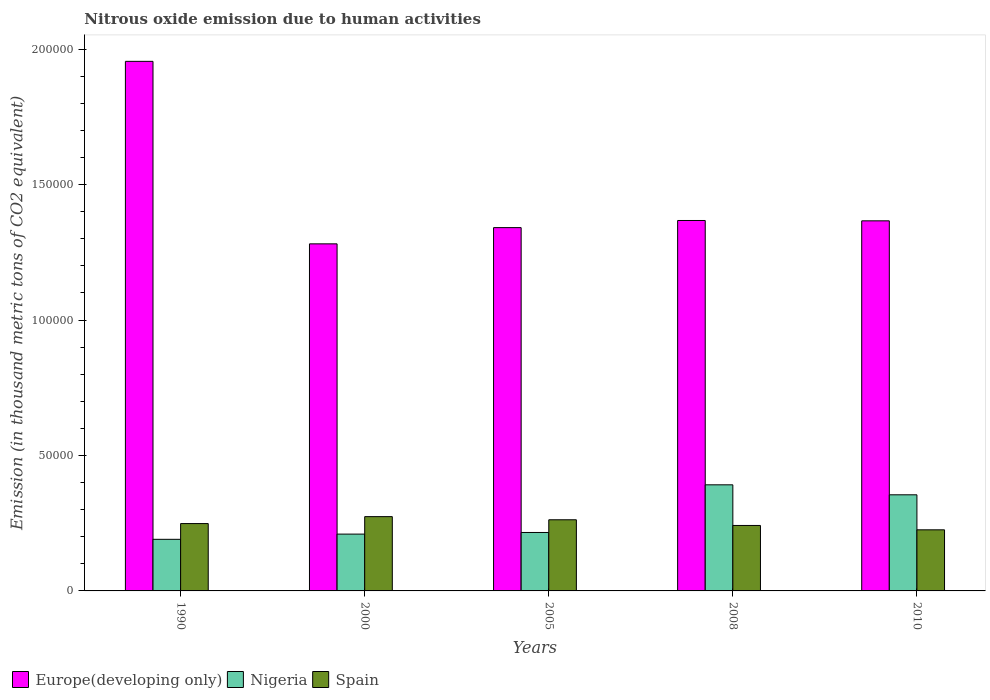How many bars are there on the 1st tick from the left?
Your answer should be compact. 3. What is the label of the 1st group of bars from the left?
Keep it short and to the point. 1990. What is the amount of nitrous oxide emitted in Spain in 2010?
Keep it short and to the point. 2.26e+04. Across all years, what is the maximum amount of nitrous oxide emitted in Nigeria?
Offer a very short reply. 3.92e+04. Across all years, what is the minimum amount of nitrous oxide emitted in Spain?
Offer a very short reply. 2.26e+04. In which year was the amount of nitrous oxide emitted in Nigeria maximum?
Provide a short and direct response. 2008. In which year was the amount of nitrous oxide emitted in Spain minimum?
Ensure brevity in your answer.  2010. What is the total amount of nitrous oxide emitted in Europe(developing only) in the graph?
Ensure brevity in your answer.  7.31e+05. What is the difference between the amount of nitrous oxide emitted in Spain in 2005 and that in 2008?
Give a very brief answer. 2102.5. What is the difference between the amount of nitrous oxide emitted in Spain in 2010 and the amount of nitrous oxide emitted in Europe(developing only) in 2005?
Offer a terse response. -1.12e+05. What is the average amount of nitrous oxide emitted in Europe(developing only) per year?
Provide a short and direct response. 1.46e+05. In the year 1990, what is the difference between the amount of nitrous oxide emitted in Spain and amount of nitrous oxide emitted in Nigeria?
Offer a very short reply. 5814.2. In how many years, is the amount of nitrous oxide emitted in Nigeria greater than 180000 thousand metric tons?
Your answer should be very brief. 0. What is the ratio of the amount of nitrous oxide emitted in Europe(developing only) in 1990 to that in 2000?
Give a very brief answer. 1.53. Is the amount of nitrous oxide emitted in Spain in 2000 less than that in 2005?
Your answer should be compact. No. What is the difference between the highest and the second highest amount of nitrous oxide emitted in Europe(developing only)?
Offer a very short reply. 5.87e+04. What is the difference between the highest and the lowest amount of nitrous oxide emitted in Nigeria?
Offer a very short reply. 2.01e+04. What does the 1st bar from the left in 2010 represents?
Give a very brief answer. Europe(developing only). What is the difference between two consecutive major ticks on the Y-axis?
Your answer should be compact. 5.00e+04. Are the values on the major ticks of Y-axis written in scientific E-notation?
Your response must be concise. No. How are the legend labels stacked?
Provide a short and direct response. Horizontal. What is the title of the graph?
Offer a terse response. Nitrous oxide emission due to human activities. Does "Namibia" appear as one of the legend labels in the graph?
Offer a very short reply. No. What is the label or title of the Y-axis?
Offer a very short reply. Emission (in thousand metric tons of CO2 equivalent). What is the Emission (in thousand metric tons of CO2 equivalent) in Europe(developing only) in 1990?
Provide a short and direct response. 1.95e+05. What is the Emission (in thousand metric tons of CO2 equivalent) of Nigeria in 1990?
Your answer should be very brief. 1.90e+04. What is the Emission (in thousand metric tons of CO2 equivalent) of Spain in 1990?
Give a very brief answer. 2.49e+04. What is the Emission (in thousand metric tons of CO2 equivalent) of Europe(developing only) in 2000?
Ensure brevity in your answer.  1.28e+05. What is the Emission (in thousand metric tons of CO2 equivalent) of Nigeria in 2000?
Offer a very short reply. 2.10e+04. What is the Emission (in thousand metric tons of CO2 equivalent) of Spain in 2000?
Ensure brevity in your answer.  2.74e+04. What is the Emission (in thousand metric tons of CO2 equivalent) of Europe(developing only) in 2005?
Provide a succinct answer. 1.34e+05. What is the Emission (in thousand metric tons of CO2 equivalent) in Nigeria in 2005?
Offer a terse response. 2.16e+04. What is the Emission (in thousand metric tons of CO2 equivalent) of Spain in 2005?
Your answer should be compact. 2.63e+04. What is the Emission (in thousand metric tons of CO2 equivalent) of Europe(developing only) in 2008?
Your answer should be compact. 1.37e+05. What is the Emission (in thousand metric tons of CO2 equivalent) of Nigeria in 2008?
Provide a short and direct response. 3.92e+04. What is the Emission (in thousand metric tons of CO2 equivalent) of Spain in 2008?
Offer a terse response. 2.42e+04. What is the Emission (in thousand metric tons of CO2 equivalent) of Europe(developing only) in 2010?
Make the answer very short. 1.37e+05. What is the Emission (in thousand metric tons of CO2 equivalent) of Nigeria in 2010?
Give a very brief answer. 3.55e+04. What is the Emission (in thousand metric tons of CO2 equivalent) of Spain in 2010?
Provide a short and direct response. 2.26e+04. Across all years, what is the maximum Emission (in thousand metric tons of CO2 equivalent) in Europe(developing only)?
Your response must be concise. 1.95e+05. Across all years, what is the maximum Emission (in thousand metric tons of CO2 equivalent) of Nigeria?
Make the answer very short. 3.92e+04. Across all years, what is the maximum Emission (in thousand metric tons of CO2 equivalent) of Spain?
Provide a short and direct response. 2.74e+04. Across all years, what is the minimum Emission (in thousand metric tons of CO2 equivalent) in Europe(developing only)?
Your response must be concise. 1.28e+05. Across all years, what is the minimum Emission (in thousand metric tons of CO2 equivalent) of Nigeria?
Keep it short and to the point. 1.90e+04. Across all years, what is the minimum Emission (in thousand metric tons of CO2 equivalent) of Spain?
Give a very brief answer. 2.26e+04. What is the total Emission (in thousand metric tons of CO2 equivalent) in Europe(developing only) in the graph?
Your response must be concise. 7.31e+05. What is the total Emission (in thousand metric tons of CO2 equivalent) in Nigeria in the graph?
Your answer should be very brief. 1.36e+05. What is the total Emission (in thousand metric tons of CO2 equivalent) in Spain in the graph?
Give a very brief answer. 1.25e+05. What is the difference between the Emission (in thousand metric tons of CO2 equivalent) of Europe(developing only) in 1990 and that in 2000?
Offer a terse response. 6.74e+04. What is the difference between the Emission (in thousand metric tons of CO2 equivalent) in Nigeria in 1990 and that in 2000?
Your answer should be compact. -1924. What is the difference between the Emission (in thousand metric tons of CO2 equivalent) of Spain in 1990 and that in 2000?
Offer a terse response. -2560.3. What is the difference between the Emission (in thousand metric tons of CO2 equivalent) of Europe(developing only) in 1990 and that in 2005?
Offer a terse response. 6.14e+04. What is the difference between the Emission (in thousand metric tons of CO2 equivalent) of Nigeria in 1990 and that in 2005?
Make the answer very short. -2524.4. What is the difference between the Emission (in thousand metric tons of CO2 equivalent) in Spain in 1990 and that in 2005?
Give a very brief answer. -1400.7. What is the difference between the Emission (in thousand metric tons of CO2 equivalent) of Europe(developing only) in 1990 and that in 2008?
Your answer should be very brief. 5.87e+04. What is the difference between the Emission (in thousand metric tons of CO2 equivalent) of Nigeria in 1990 and that in 2008?
Your answer should be very brief. -2.01e+04. What is the difference between the Emission (in thousand metric tons of CO2 equivalent) of Spain in 1990 and that in 2008?
Your answer should be compact. 701.8. What is the difference between the Emission (in thousand metric tons of CO2 equivalent) of Europe(developing only) in 1990 and that in 2010?
Offer a very short reply. 5.89e+04. What is the difference between the Emission (in thousand metric tons of CO2 equivalent) in Nigeria in 1990 and that in 2010?
Give a very brief answer. -1.64e+04. What is the difference between the Emission (in thousand metric tons of CO2 equivalent) of Spain in 1990 and that in 2010?
Give a very brief answer. 2311.7. What is the difference between the Emission (in thousand metric tons of CO2 equivalent) in Europe(developing only) in 2000 and that in 2005?
Offer a very short reply. -5992.3. What is the difference between the Emission (in thousand metric tons of CO2 equivalent) of Nigeria in 2000 and that in 2005?
Provide a succinct answer. -600.4. What is the difference between the Emission (in thousand metric tons of CO2 equivalent) in Spain in 2000 and that in 2005?
Provide a short and direct response. 1159.6. What is the difference between the Emission (in thousand metric tons of CO2 equivalent) of Europe(developing only) in 2000 and that in 2008?
Make the answer very short. -8618.7. What is the difference between the Emission (in thousand metric tons of CO2 equivalent) in Nigeria in 2000 and that in 2008?
Offer a terse response. -1.82e+04. What is the difference between the Emission (in thousand metric tons of CO2 equivalent) of Spain in 2000 and that in 2008?
Offer a very short reply. 3262.1. What is the difference between the Emission (in thousand metric tons of CO2 equivalent) in Europe(developing only) in 2000 and that in 2010?
Make the answer very short. -8495.7. What is the difference between the Emission (in thousand metric tons of CO2 equivalent) in Nigeria in 2000 and that in 2010?
Make the answer very short. -1.45e+04. What is the difference between the Emission (in thousand metric tons of CO2 equivalent) in Spain in 2000 and that in 2010?
Offer a terse response. 4872. What is the difference between the Emission (in thousand metric tons of CO2 equivalent) in Europe(developing only) in 2005 and that in 2008?
Ensure brevity in your answer.  -2626.4. What is the difference between the Emission (in thousand metric tons of CO2 equivalent) in Nigeria in 2005 and that in 2008?
Your answer should be compact. -1.76e+04. What is the difference between the Emission (in thousand metric tons of CO2 equivalent) of Spain in 2005 and that in 2008?
Your answer should be very brief. 2102.5. What is the difference between the Emission (in thousand metric tons of CO2 equivalent) of Europe(developing only) in 2005 and that in 2010?
Offer a terse response. -2503.4. What is the difference between the Emission (in thousand metric tons of CO2 equivalent) of Nigeria in 2005 and that in 2010?
Keep it short and to the point. -1.39e+04. What is the difference between the Emission (in thousand metric tons of CO2 equivalent) in Spain in 2005 and that in 2010?
Give a very brief answer. 3712.4. What is the difference between the Emission (in thousand metric tons of CO2 equivalent) of Europe(developing only) in 2008 and that in 2010?
Keep it short and to the point. 123. What is the difference between the Emission (in thousand metric tons of CO2 equivalent) of Nigeria in 2008 and that in 2010?
Your answer should be compact. 3687.6. What is the difference between the Emission (in thousand metric tons of CO2 equivalent) in Spain in 2008 and that in 2010?
Ensure brevity in your answer.  1609.9. What is the difference between the Emission (in thousand metric tons of CO2 equivalent) in Europe(developing only) in 1990 and the Emission (in thousand metric tons of CO2 equivalent) in Nigeria in 2000?
Ensure brevity in your answer.  1.74e+05. What is the difference between the Emission (in thousand metric tons of CO2 equivalent) in Europe(developing only) in 1990 and the Emission (in thousand metric tons of CO2 equivalent) in Spain in 2000?
Provide a short and direct response. 1.68e+05. What is the difference between the Emission (in thousand metric tons of CO2 equivalent) in Nigeria in 1990 and the Emission (in thousand metric tons of CO2 equivalent) in Spain in 2000?
Your response must be concise. -8374.5. What is the difference between the Emission (in thousand metric tons of CO2 equivalent) in Europe(developing only) in 1990 and the Emission (in thousand metric tons of CO2 equivalent) in Nigeria in 2005?
Ensure brevity in your answer.  1.74e+05. What is the difference between the Emission (in thousand metric tons of CO2 equivalent) of Europe(developing only) in 1990 and the Emission (in thousand metric tons of CO2 equivalent) of Spain in 2005?
Make the answer very short. 1.69e+05. What is the difference between the Emission (in thousand metric tons of CO2 equivalent) in Nigeria in 1990 and the Emission (in thousand metric tons of CO2 equivalent) in Spain in 2005?
Give a very brief answer. -7214.9. What is the difference between the Emission (in thousand metric tons of CO2 equivalent) in Europe(developing only) in 1990 and the Emission (in thousand metric tons of CO2 equivalent) in Nigeria in 2008?
Your response must be concise. 1.56e+05. What is the difference between the Emission (in thousand metric tons of CO2 equivalent) of Europe(developing only) in 1990 and the Emission (in thousand metric tons of CO2 equivalent) of Spain in 2008?
Provide a succinct answer. 1.71e+05. What is the difference between the Emission (in thousand metric tons of CO2 equivalent) in Nigeria in 1990 and the Emission (in thousand metric tons of CO2 equivalent) in Spain in 2008?
Your answer should be very brief. -5112.4. What is the difference between the Emission (in thousand metric tons of CO2 equivalent) in Europe(developing only) in 1990 and the Emission (in thousand metric tons of CO2 equivalent) in Nigeria in 2010?
Provide a short and direct response. 1.60e+05. What is the difference between the Emission (in thousand metric tons of CO2 equivalent) of Europe(developing only) in 1990 and the Emission (in thousand metric tons of CO2 equivalent) of Spain in 2010?
Ensure brevity in your answer.  1.73e+05. What is the difference between the Emission (in thousand metric tons of CO2 equivalent) in Nigeria in 1990 and the Emission (in thousand metric tons of CO2 equivalent) in Spain in 2010?
Keep it short and to the point. -3502.5. What is the difference between the Emission (in thousand metric tons of CO2 equivalent) in Europe(developing only) in 2000 and the Emission (in thousand metric tons of CO2 equivalent) in Nigeria in 2005?
Offer a very short reply. 1.07e+05. What is the difference between the Emission (in thousand metric tons of CO2 equivalent) in Europe(developing only) in 2000 and the Emission (in thousand metric tons of CO2 equivalent) in Spain in 2005?
Your answer should be very brief. 1.02e+05. What is the difference between the Emission (in thousand metric tons of CO2 equivalent) in Nigeria in 2000 and the Emission (in thousand metric tons of CO2 equivalent) in Spain in 2005?
Provide a short and direct response. -5290.9. What is the difference between the Emission (in thousand metric tons of CO2 equivalent) of Europe(developing only) in 2000 and the Emission (in thousand metric tons of CO2 equivalent) of Nigeria in 2008?
Your answer should be very brief. 8.89e+04. What is the difference between the Emission (in thousand metric tons of CO2 equivalent) in Europe(developing only) in 2000 and the Emission (in thousand metric tons of CO2 equivalent) in Spain in 2008?
Give a very brief answer. 1.04e+05. What is the difference between the Emission (in thousand metric tons of CO2 equivalent) in Nigeria in 2000 and the Emission (in thousand metric tons of CO2 equivalent) in Spain in 2008?
Give a very brief answer. -3188.4. What is the difference between the Emission (in thousand metric tons of CO2 equivalent) of Europe(developing only) in 2000 and the Emission (in thousand metric tons of CO2 equivalent) of Nigeria in 2010?
Your answer should be very brief. 9.26e+04. What is the difference between the Emission (in thousand metric tons of CO2 equivalent) of Europe(developing only) in 2000 and the Emission (in thousand metric tons of CO2 equivalent) of Spain in 2010?
Offer a terse response. 1.06e+05. What is the difference between the Emission (in thousand metric tons of CO2 equivalent) in Nigeria in 2000 and the Emission (in thousand metric tons of CO2 equivalent) in Spain in 2010?
Make the answer very short. -1578.5. What is the difference between the Emission (in thousand metric tons of CO2 equivalent) of Europe(developing only) in 2005 and the Emission (in thousand metric tons of CO2 equivalent) of Nigeria in 2008?
Provide a succinct answer. 9.49e+04. What is the difference between the Emission (in thousand metric tons of CO2 equivalent) of Europe(developing only) in 2005 and the Emission (in thousand metric tons of CO2 equivalent) of Spain in 2008?
Ensure brevity in your answer.  1.10e+05. What is the difference between the Emission (in thousand metric tons of CO2 equivalent) of Nigeria in 2005 and the Emission (in thousand metric tons of CO2 equivalent) of Spain in 2008?
Your response must be concise. -2588. What is the difference between the Emission (in thousand metric tons of CO2 equivalent) in Europe(developing only) in 2005 and the Emission (in thousand metric tons of CO2 equivalent) in Nigeria in 2010?
Your answer should be compact. 9.86e+04. What is the difference between the Emission (in thousand metric tons of CO2 equivalent) of Europe(developing only) in 2005 and the Emission (in thousand metric tons of CO2 equivalent) of Spain in 2010?
Your response must be concise. 1.12e+05. What is the difference between the Emission (in thousand metric tons of CO2 equivalent) in Nigeria in 2005 and the Emission (in thousand metric tons of CO2 equivalent) in Spain in 2010?
Keep it short and to the point. -978.1. What is the difference between the Emission (in thousand metric tons of CO2 equivalent) of Europe(developing only) in 2008 and the Emission (in thousand metric tons of CO2 equivalent) of Nigeria in 2010?
Provide a short and direct response. 1.01e+05. What is the difference between the Emission (in thousand metric tons of CO2 equivalent) of Europe(developing only) in 2008 and the Emission (in thousand metric tons of CO2 equivalent) of Spain in 2010?
Provide a short and direct response. 1.14e+05. What is the difference between the Emission (in thousand metric tons of CO2 equivalent) of Nigeria in 2008 and the Emission (in thousand metric tons of CO2 equivalent) of Spain in 2010?
Your response must be concise. 1.66e+04. What is the average Emission (in thousand metric tons of CO2 equivalent) of Europe(developing only) per year?
Offer a terse response. 1.46e+05. What is the average Emission (in thousand metric tons of CO2 equivalent) in Nigeria per year?
Your answer should be very brief. 2.72e+04. What is the average Emission (in thousand metric tons of CO2 equivalent) of Spain per year?
Offer a very short reply. 2.51e+04. In the year 1990, what is the difference between the Emission (in thousand metric tons of CO2 equivalent) in Europe(developing only) and Emission (in thousand metric tons of CO2 equivalent) in Nigeria?
Your answer should be very brief. 1.76e+05. In the year 1990, what is the difference between the Emission (in thousand metric tons of CO2 equivalent) in Europe(developing only) and Emission (in thousand metric tons of CO2 equivalent) in Spain?
Your answer should be very brief. 1.71e+05. In the year 1990, what is the difference between the Emission (in thousand metric tons of CO2 equivalent) in Nigeria and Emission (in thousand metric tons of CO2 equivalent) in Spain?
Your answer should be very brief. -5814.2. In the year 2000, what is the difference between the Emission (in thousand metric tons of CO2 equivalent) of Europe(developing only) and Emission (in thousand metric tons of CO2 equivalent) of Nigeria?
Provide a succinct answer. 1.07e+05. In the year 2000, what is the difference between the Emission (in thousand metric tons of CO2 equivalent) of Europe(developing only) and Emission (in thousand metric tons of CO2 equivalent) of Spain?
Offer a very short reply. 1.01e+05. In the year 2000, what is the difference between the Emission (in thousand metric tons of CO2 equivalent) in Nigeria and Emission (in thousand metric tons of CO2 equivalent) in Spain?
Provide a succinct answer. -6450.5. In the year 2005, what is the difference between the Emission (in thousand metric tons of CO2 equivalent) in Europe(developing only) and Emission (in thousand metric tons of CO2 equivalent) in Nigeria?
Your answer should be very brief. 1.13e+05. In the year 2005, what is the difference between the Emission (in thousand metric tons of CO2 equivalent) of Europe(developing only) and Emission (in thousand metric tons of CO2 equivalent) of Spain?
Offer a very short reply. 1.08e+05. In the year 2005, what is the difference between the Emission (in thousand metric tons of CO2 equivalent) of Nigeria and Emission (in thousand metric tons of CO2 equivalent) of Spain?
Make the answer very short. -4690.5. In the year 2008, what is the difference between the Emission (in thousand metric tons of CO2 equivalent) in Europe(developing only) and Emission (in thousand metric tons of CO2 equivalent) in Nigeria?
Your response must be concise. 9.76e+04. In the year 2008, what is the difference between the Emission (in thousand metric tons of CO2 equivalent) in Europe(developing only) and Emission (in thousand metric tons of CO2 equivalent) in Spain?
Provide a succinct answer. 1.13e+05. In the year 2008, what is the difference between the Emission (in thousand metric tons of CO2 equivalent) in Nigeria and Emission (in thousand metric tons of CO2 equivalent) in Spain?
Offer a terse response. 1.50e+04. In the year 2010, what is the difference between the Emission (in thousand metric tons of CO2 equivalent) in Europe(developing only) and Emission (in thousand metric tons of CO2 equivalent) in Nigeria?
Your response must be concise. 1.01e+05. In the year 2010, what is the difference between the Emission (in thousand metric tons of CO2 equivalent) in Europe(developing only) and Emission (in thousand metric tons of CO2 equivalent) in Spain?
Keep it short and to the point. 1.14e+05. In the year 2010, what is the difference between the Emission (in thousand metric tons of CO2 equivalent) in Nigeria and Emission (in thousand metric tons of CO2 equivalent) in Spain?
Provide a short and direct response. 1.29e+04. What is the ratio of the Emission (in thousand metric tons of CO2 equivalent) in Europe(developing only) in 1990 to that in 2000?
Keep it short and to the point. 1.53. What is the ratio of the Emission (in thousand metric tons of CO2 equivalent) of Nigeria in 1990 to that in 2000?
Ensure brevity in your answer.  0.91. What is the ratio of the Emission (in thousand metric tons of CO2 equivalent) of Spain in 1990 to that in 2000?
Provide a succinct answer. 0.91. What is the ratio of the Emission (in thousand metric tons of CO2 equivalent) of Europe(developing only) in 1990 to that in 2005?
Your response must be concise. 1.46. What is the ratio of the Emission (in thousand metric tons of CO2 equivalent) in Nigeria in 1990 to that in 2005?
Provide a succinct answer. 0.88. What is the ratio of the Emission (in thousand metric tons of CO2 equivalent) in Spain in 1990 to that in 2005?
Offer a very short reply. 0.95. What is the ratio of the Emission (in thousand metric tons of CO2 equivalent) in Europe(developing only) in 1990 to that in 2008?
Provide a succinct answer. 1.43. What is the ratio of the Emission (in thousand metric tons of CO2 equivalent) in Nigeria in 1990 to that in 2008?
Provide a short and direct response. 0.49. What is the ratio of the Emission (in thousand metric tons of CO2 equivalent) of Europe(developing only) in 1990 to that in 2010?
Your response must be concise. 1.43. What is the ratio of the Emission (in thousand metric tons of CO2 equivalent) of Nigeria in 1990 to that in 2010?
Give a very brief answer. 0.54. What is the ratio of the Emission (in thousand metric tons of CO2 equivalent) in Spain in 1990 to that in 2010?
Your response must be concise. 1.1. What is the ratio of the Emission (in thousand metric tons of CO2 equivalent) of Europe(developing only) in 2000 to that in 2005?
Give a very brief answer. 0.96. What is the ratio of the Emission (in thousand metric tons of CO2 equivalent) of Nigeria in 2000 to that in 2005?
Your answer should be very brief. 0.97. What is the ratio of the Emission (in thousand metric tons of CO2 equivalent) of Spain in 2000 to that in 2005?
Give a very brief answer. 1.04. What is the ratio of the Emission (in thousand metric tons of CO2 equivalent) of Europe(developing only) in 2000 to that in 2008?
Provide a succinct answer. 0.94. What is the ratio of the Emission (in thousand metric tons of CO2 equivalent) of Nigeria in 2000 to that in 2008?
Give a very brief answer. 0.54. What is the ratio of the Emission (in thousand metric tons of CO2 equivalent) of Spain in 2000 to that in 2008?
Give a very brief answer. 1.14. What is the ratio of the Emission (in thousand metric tons of CO2 equivalent) of Europe(developing only) in 2000 to that in 2010?
Your response must be concise. 0.94. What is the ratio of the Emission (in thousand metric tons of CO2 equivalent) of Nigeria in 2000 to that in 2010?
Keep it short and to the point. 0.59. What is the ratio of the Emission (in thousand metric tons of CO2 equivalent) in Spain in 2000 to that in 2010?
Offer a terse response. 1.22. What is the ratio of the Emission (in thousand metric tons of CO2 equivalent) in Europe(developing only) in 2005 to that in 2008?
Offer a very short reply. 0.98. What is the ratio of the Emission (in thousand metric tons of CO2 equivalent) of Nigeria in 2005 to that in 2008?
Make the answer very short. 0.55. What is the ratio of the Emission (in thousand metric tons of CO2 equivalent) in Spain in 2005 to that in 2008?
Your response must be concise. 1.09. What is the ratio of the Emission (in thousand metric tons of CO2 equivalent) in Europe(developing only) in 2005 to that in 2010?
Keep it short and to the point. 0.98. What is the ratio of the Emission (in thousand metric tons of CO2 equivalent) of Nigeria in 2005 to that in 2010?
Your answer should be very brief. 0.61. What is the ratio of the Emission (in thousand metric tons of CO2 equivalent) in Spain in 2005 to that in 2010?
Provide a succinct answer. 1.16. What is the ratio of the Emission (in thousand metric tons of CO2 equivalent) in Europe(developing only) in 2008 to that in 2010?
Provide a short and direct response. 1. What is the ratio of the Emission (in thousand metric tons of CO2 equivalent) in Nigeria in 2008 to that in 2010?
Provide a short and direct response. 1.1. What is the ratio of the Emission (in thousand metric tons of CO2 equivalent) in Spain in 2008 to that in 2010?
Make the answer very short. 1.07. What is the difference between the highest and the second highest Emission (in thousand metric tons of CO2 equivalent) of Europe(developing only)?
Your response must be concise. 5.87e+04. What is the difference between the highest and the second highest Emission (in thousand metric tons of CO2 equivalent) of Nigeria?
Ensure brevity in your answer.  3687.6. What is the difference between the highest and the second highest Emission (in thousand metric tons of CO2 equivalent) of Spain?
Give a very brief answer. 1159.6. What is the difference between the highest and the lowest Emission (in thousand metric tons of CO2 equivalent) of Europe(developing only)?
Your response must be concise. 6.74e+04. What is the difference between the highest and the lowest Emission (in thousand metric tons of CO2 equivalent) in Nigeria?
Your answer should be compact. 2.01e+04. What is the difference between the highest and the lowest Emission (in thousand metric tons of CO2 equivalent) of Spain?
Your answer should be very brief. 4872. 